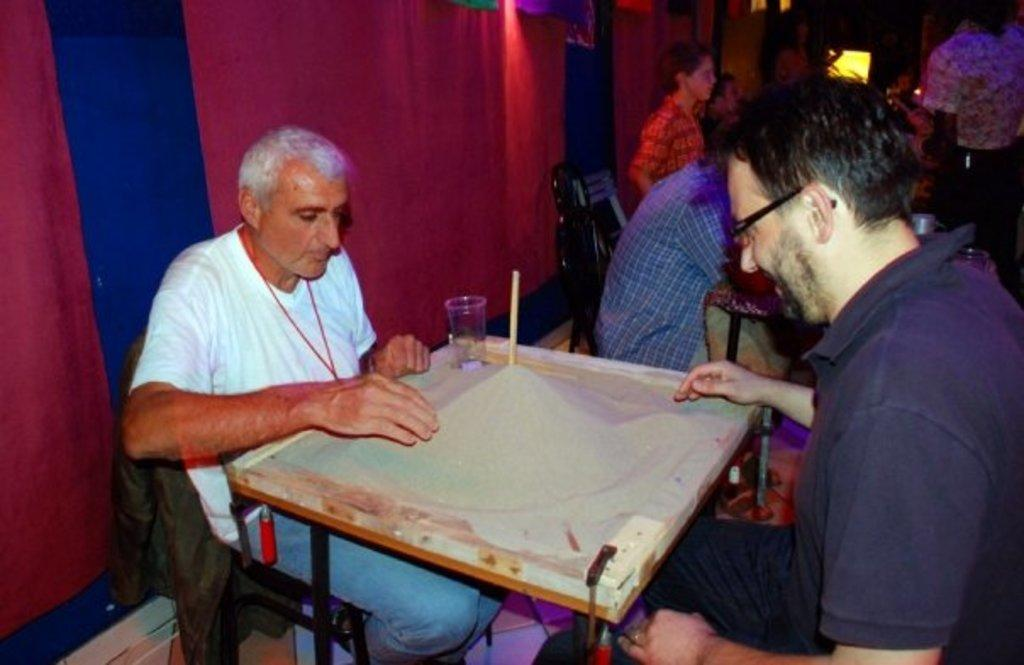How many people are in the image? There are two guys in the image. What are the guys doing in the image? The guys are playing on a board. What is on the board? The board has sand on it, a stick, and a glass. What can be seen in the background of the image? There is a red curtain in the background of the image. Can you see a branch arching over the guys in the image? There is no branch or arch visible in the image; it only shows two guys playing on a board with sand, a stick, and a glass on it, and a red curtain in the background. 